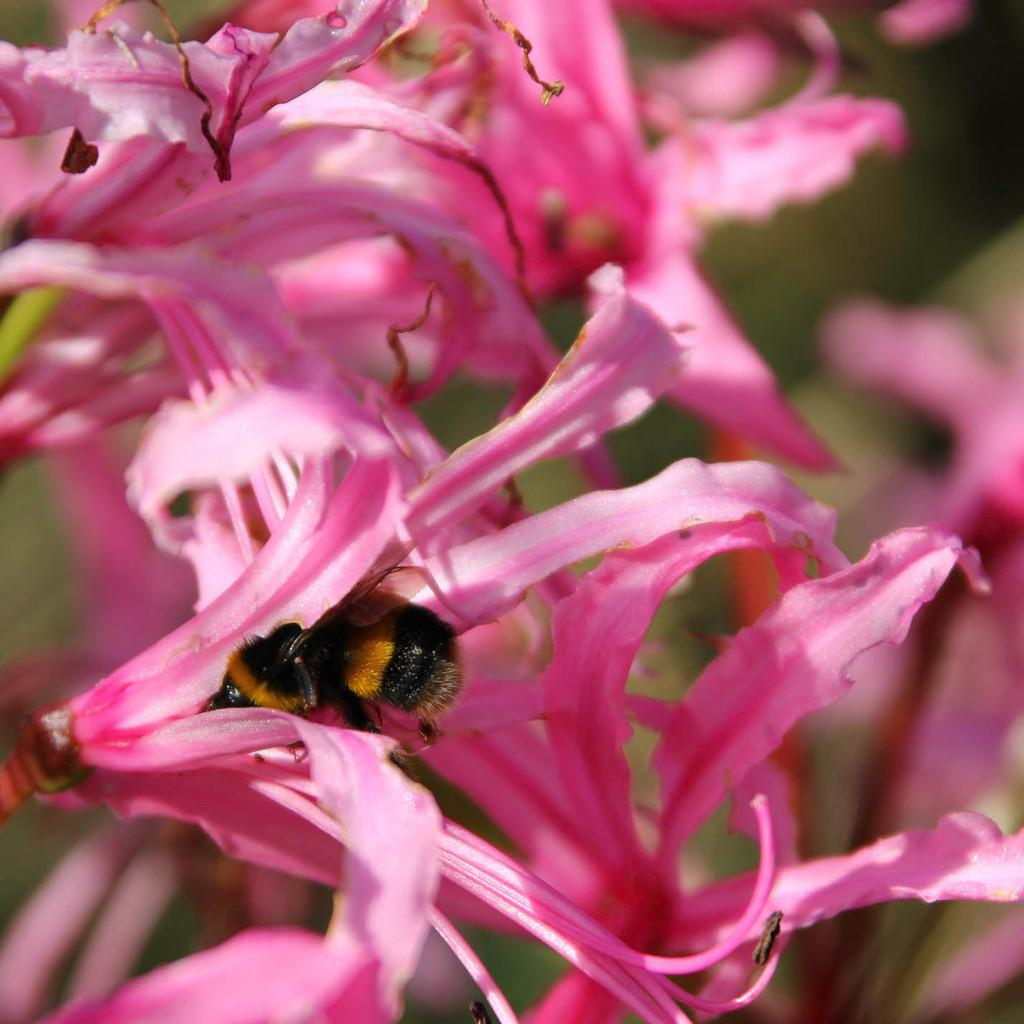What type of plants are in the image? There are flowers in the image. What color are the petals of the flowers? The flowers have pink petals. Can you describe any living organisms interacting with the flowers? Yes, there is a honey bee inside a flower. How would you describe the background of the image? The background of the image is blurry. What type of farm can be seen in the background of the image? There is no farm visible in the image; the background is blurry. How does the moon affect the growth of the flowers in the image? The moon is not present in the image, so it cannot affect the growth of the flowers. 